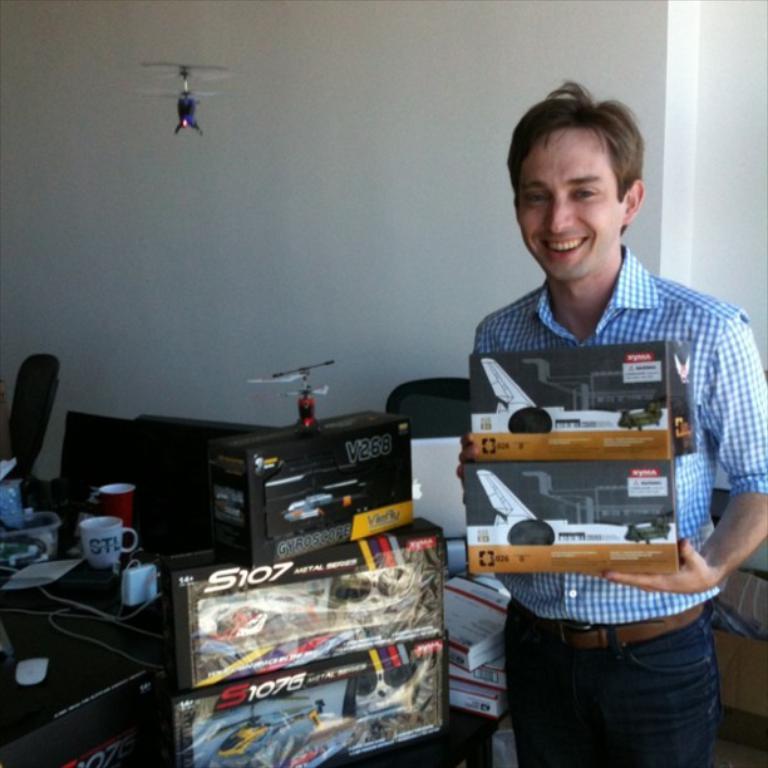What is the model airplane model number?
Ensure brevity in your answer.  S107. 